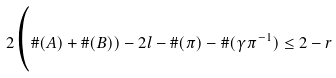Convert formula to latex. <formula><loc_0><loc_0><loc_500><loc_500>2 \Big ( \# ( A ) + \# ( B ) ) - 2 l - \# ( \pi ) - \# ( \gamma \pi ^ { - 1 } ) \leq 2 - r</formula> 